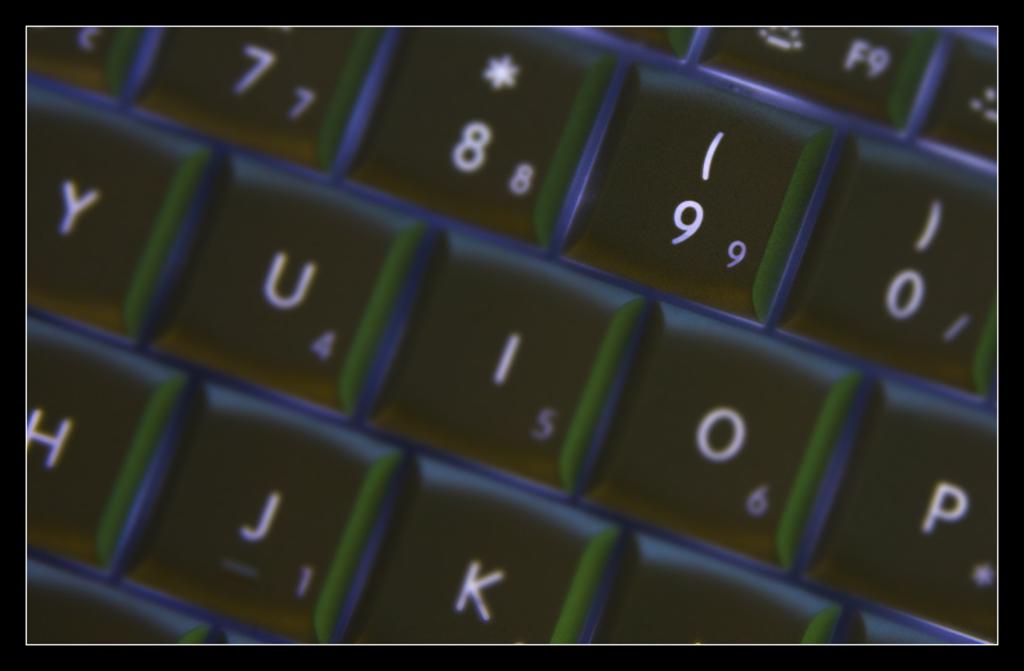What number is below the j key?
Your answer should be very brief. 1. What number seems to shine the brightest?
Provide a short and direct response. 9. 